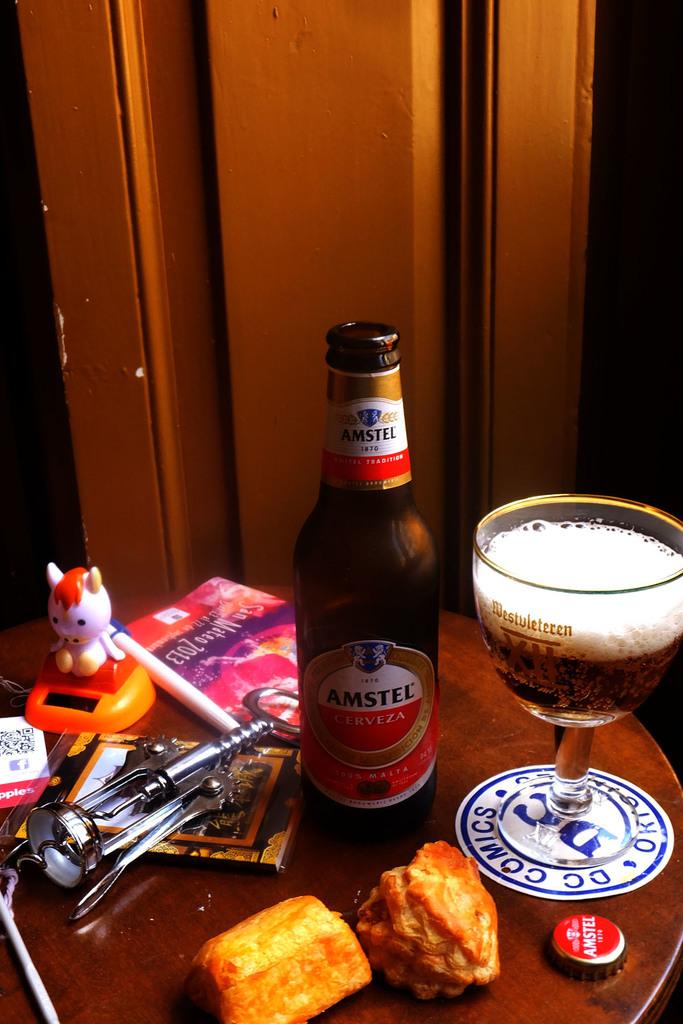The coaster is what kind of comics?
Ensure brevity in your answer.  Dc. What brand beer is in the bottle?
Your answer should be compact. Amstel. 